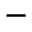<formula> <loc_0><loc_0><loc_500><loc_500>^ { - }</formula> 